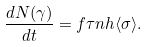Convert formula to latex. <formula><loc_0><loc_0><loc_500><loc_500>\frac { d N ( \gamma ) } { d t } = f \tau n h \langle \sigma \rangle .</formula> 